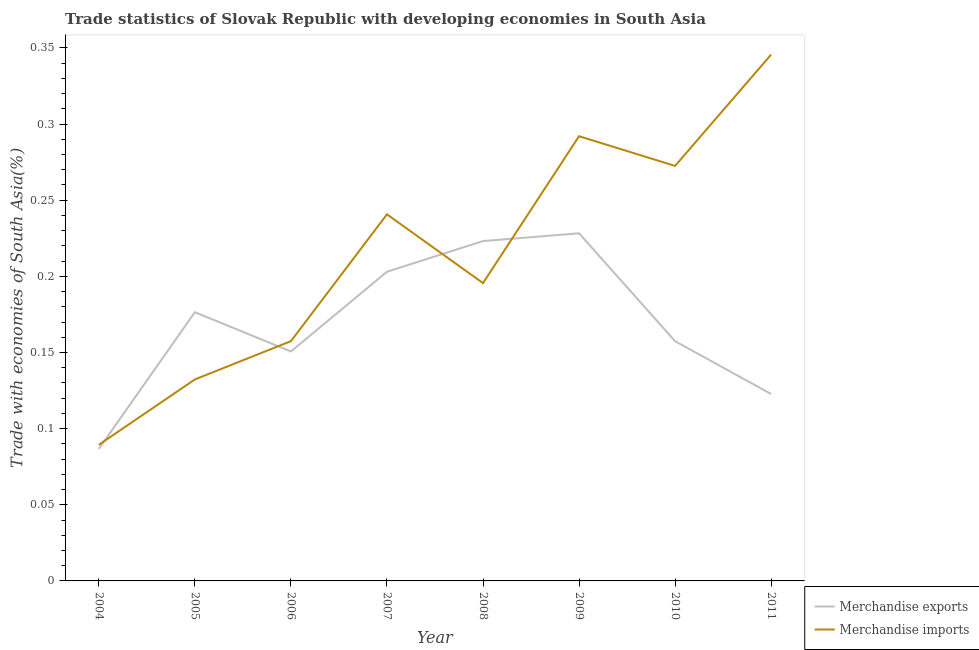Does the line corresponding to merchandise imports intersect with the line corresponding to merchandise exports?
Provide a short and direct response. Yes. Is the number of lines equal to the number of legend labels?
Your answer should be very brief. Yes. What is the merchandise exports in 2004?
Offer a terse response. 0.09. Across all years, what is the maximum merchandise exports?
Ensure brevity in your answer.  0.23. Across all years, what is the minimum merchandise imports?
Keep it short and to the point. 0.09. In which year was the merchandise imports maximum?
Your response must be concise. 2011. In which year was the merchandise imports minimum?
Give a very brief answer. 2004. What is the total merchandise exports in the graph?
Give a very brief answer. 1.35. What is the difference between the merchandise imports in 2006 and that in 2010?
Offer a very short reply. -0.12. What is the difference between the merchandise exports in 2011 and the merchandise imports in 2005?
Offer a very short reply. -0.01. What is the average merchandise exports per year?
Make the answer very short. 0.17. In the year 2004, what is the difference between the merchandise imports and merchandise exports?
Offer a very short reply. 0. In how many years, is the merchandise exports greater than 0.12000000000000001 %?
Keep it short and to the point. 7. What is the ratio of the merchandise imports in 2005 to that in 2006?
Your response must be concise. 0.84. What is the difference between the highest and the second highest merchandise imports?
Make the answer very short. 0.05. What is the difference between the highest and the lowest merchandise imports?
Provide a short and direct response. 0.26. In how many years, is the merchandise exports greater than the average merchandise exports taken over all years?
Your response must be concise. 4. Is the merchandise exports strictly less than the merchandise imports over the years?
Keep it short and to the point. No. How many lines are there?
Your answer should be compact. 2. How many years are there in the graph?
Make the answer very short. 8. What is the difference between two consecutive major ticks on the Y-axis?
Offer a terse response. 0.05. Are the values on the major ticks of Y-axis written in scientific E-notation?
Give a very brief answer. No. What is the title of the graph?
Offer a very short reply. Trade statistics of Slovak Republic with developing economies in South Asia. Does "Non-resident workers" appear as one of the legend labels in the graph?
Your answer should be very brief. No. What is the label or title of the Y-axis?
Your answer should be very brief. Trade with economies of South Asia(%). What is the Trade with economies of South Asia(%) in Merchandise exports in 2004?
Your answer should be compact. 0.09. What is the Trade with economies of South Asia(%) in Merchandise imports in 2004?
Give a very brief answer. 0.09. What is the Trade with economies of South Asia(%) of Merchandise exports in 2005?
Make the answer very short. 0.18. What is the Trade with economies of South Asia(%) of Merchandise imports in 2005?
Offer a very short reply. 0.13. What is the Trade with economies of South Asia(%) in Merchandise exports in 2006?
Ensure brevity in your answer.  0.15. What is the Trade with economies of South Asia(%) of Merchandise imports in 2006?
Your answer should be very brief. 0.16. What is the Trade with economies of South Asia(%) of Merchandise exports in 2007?
Keep it short and to the point. 0.2. What is the Trade with economies of South Asia(%) of Merchandise imports in 2007?
Offer a very short reply. 0.24. What is the Trade with economies of South Asia(%) of Merchandise exports in 2008?
Offer a very short reply. 0.22. What is the Trade with economies of South Asia(%) in Merchandise imports in 2008?
Offer a terse response. 0.2. What is the Trade with economies of South Asia(%) of Merchandise exports in 2009?
Make the answer very short. 0.23. What is the Trade with economies of South Asia(%) of Merchandise imports in 2009?
Your answer should be very brief. 0.29. What is the Trade with economies of South Asia(%) in Merchandise exports in 2010?
Your answer should be compact. 0.16. What is the Trade with economies of South Asia(%) of Merchandise imports in 2010?
Offer a terse response. 0.27. What is the Trade with economies of South Asia(%) of Merchandise exports in 2011?
Your response must be concise. 0.12. What is the Trade with economies of South Asia(%) in Merchandise imports in 2011?
Offer a terse response. 0.35. Across all years, what is the maximum Trade with economies of South Asia(%) in Merchandise exports?
Keep it short and to the point. 0.23. Across all years, what is the maximum Trade with economies of South Asia(%) of Merchandise imports?
Make the answer very short. 0.35. Across all years, what is the minimum Trade with economies of South Asia(%) of Merchandise exports?
Offer a terse response. 0.09. Across all years, what is the minimum Trade with economies of South Asia(%) in Merchandise imports?
Your answer should be compact. 0.09. What is the total Trade with economies of South Asia(%) in Merchandise exports in the graph?
Make the answer very short. 1.35. What is the total Trade with economies of South Asia(%) in Merchandise imports in the graph?
Make the answer very short. 1.73. What is the difference between the Trade with economies of South Asia(%) in Merchandise exports in 2004 and that in 2005?
Offer a very short reply. -0.09. What is the difference between the Trade with economies of South Asia(%) in Merchandise imports in 2004 and that in 2005?
Make the answer very short. -0.04. What is the difference between the Trade with economies of South Asia(%) in Merchandise exports in 2004 and that in 2006?
Offer a very short reply. -0.06. What is the difference between the Trade with economies of South Asia(%) of Merchandise imports in 2004 and that in 2006?
Give a very brief answer. -0.07. What is the difference between the Trade with economies of South Asia(%) of Merchandise exports in 2004 and that in 2007?
Your answer should be compact. -0.12. What is the difference between the Trade with economies of South Asia(%) in Merchandise imports in 2004 and that in 2007?
Make the answer very short. -0.15. What is the difference between the Trade with economies of South Asia(%) of Merchandise exports in 2004 and that in 2008?
Offer a very short reply. -0.14. What is the difference between the Trade with economies of South Asia(%) of Merchandise imports in 2004 and that in 2008?
Give a very brief answer. -0.11. What is the difference between the Trade with economies of South Asia(%) in Merchandise exports in 2004 and that in 2009?
Keep it short and to the point. -0.14. What is the difference between the Trade with economies of South Asia(%) of Merchandise imports in 2004 and that in 2009?
Give a very brief answer. -0.2. What is the difference between the Trade with economies of South Asia(%) of Merchandise exports in 2004 and that in 2010?
Your response must be concise. -0.07. What is the difference between the Trade with economies of South Asia(%) in Merchandise imports in 2004 and that in 2010?
Your response must be concise. -0.18. What is the difference between the Trade with economies of South Asia(%) in Merchandise exports in 2004 and that in 2011?
Your answer should be compact. -0.04. What is the difference between the Trade with economies of South Asia(%) in Merchandise imports in 2004 and that in 2011?
Offer a terse response. -0.26. What is the difference between the Trade with economies of South Asia(%) of Merchandise exports in 2005 and that in 2006?
Provide a succinct answer. 0.03. What is the difference between the Trade with economies of South Asia(%) of Merchandise imports in 2005 and that in 2006?
Your answer should be compact. -0.03. What is the difference between the Trade with economies of South Asia(%) of Merchandise exports in 2005 and that in 2007?
Provide a short and direct response. -0.03. What is the difference between the Trade with economies of South Asia(%) in Merchandise imports in 2005 and that in 2007?
Provide a succinct answer. -0.11. What is the difference between the Trade with economies of South Asia(%) in Merchandise exports in 2005 and that in 2008?
Offer a terse response. -0.05. What is the difference between the Trade with economies of South Asia(%) in Merchandise imports in 2005 and that in 2008?
Give a very brief answer. -0.06. What is the difference between the Trade with economies of South Asia(%) of Merchandise exports in 2005 and that in 2009?
Provide a short and direct response. -0.05. What is the difference between the Trade with economies of South Asia(%) of Merchandise imports in 2005 and that in 2009?
Offer a very short reply. -0.16. What is the difference between the Trade with economies of South Asia(%) of Merchandise exports in 2005 and that in 2010?
Your answer should be compact. 0.02. What is the difference between the Trade with economies of South Asia(%) of Merchandise imports in 2005 and that in 2010?
Ensure brevity in your answer.  -0.14. What is the difference between the Trade with economies of South Asia(%) of Merchandise exports in 2005 and that in 2011?
Your answer should be compact. 0.05. What is the difference between the Trade with economies of South Asia(%) in Merchandise imports in 2005 and that in 2011?
Keep it short and to the point. -0.21. What is the difference between the Trade with economies of South Asia(%) in Merchandise exports in 2006 and that in 2007?
Ensure brevity in your answer.  -0.05. What is the difference between the Trade with economies of South Asia(%) of Merchandise imports in 2006 and that in 2007?
Provide a short and direct response. -0.08. What is the difference between the Trade with economies of South Asia(%) in Merchandise exports in 2006 and that in 2008?
Your answer should be compact. -0.07. What is the difference between the Trade with economies of South Asia(%) of Merchandise imports in 2006 and that in 2008?
Ensure brevity in your answer.  -0.04. What is the difference between the Trade with economies of South Asia(%) of Merchandise exports in 2006 and that in 2009?
Provide a succinct answer. -0.08. What is the difference between the Trade with economies of South Asia(%) in Merchandise imports in 2006 and that in 2009?
Provide a succinct answer. -0.13. What is the difference between the Trade with economies of South Asia(%) in Merchandise exports in 2006 and that in 2010?
Make the answer very short. -0.01. What is the difference between the Trade with economies of South Asia(%) in Merchandise imports in 2006 and that in 2010?
Your answer should be very brief. -0.12. What is the difference between the Trade with economies of South Asia(%) in Merchandise exports in 2006 and that in 2011?
Offer a terse response. 0.03. What is the difference between the Trade with economies of South Asia(%) in Merchandise imports in 2006 and that in 2011?
Ensure brevity in your answer.  -0.19. What is the difference between the Trade with economies of South Asia(%) in Merchandise exports in 2007 and that in 2008?
Provide a short and direct response. -0.02. What is the difference between the Trade with economies of South Asia(%) of Merchandise imports in 2007 and that in 2008?
Provide a short and direct response. 0.05. What is the difference between the Trade with economies of South Asia(%) of Merchandise exports in 2007 and that in 2009?
Your answer should be compact. -0.03. What is the difference between the Trade with economies of South Asia(%) in Merchandise imports in 2007 and that in 2009?
Your answer should be very brief. -0.05. What is the difference between the Trade with economies of South Asia(%) of Merchandise exports in 2007 and that in 2010?
Offer a very short reply. 0.05. What is the difference between the Trade with economies of South Asia(%) of Merchandise imports in 2007 and that in 2010?
Offer a very short reply. -0.03. What is the difference between the Trade with economies of South Asia(%) of Merchandise exports in 2007 and that in 2011?
Ensure brevity in your answer.  0.08. What is the difference between the Trade with economies of South Asia(%) in Merchandise imports in 2007 and that in 2011?
Provide a succinct answer. -0.1. What is the difference between the Trade with economies of South Asia(%) of Merchandise exports in 2008 and that in 2009?
Your answer should be compact. -0.01. What is the difference between the Trade with economies of South Asia(%) in Merchandise imports in 2008 and that in 2009?
Provide a short and direct response. -0.1. What is the difference between the Trade with economies of South Asia(%) of Merchandise exports in 2008 and that in 2010?
Offer a terse response. 0.07. What is the difference between the Trade with economies of South Asia(%) of Merchandise imports in 2008 and that in 2010?
Offer a terse response. -0.08. What is the difference between the Trade with economies of South Asia(%) of Merchandise exports in 2008 and that in 2011?
Offer a very short reply. 0.1. What is the difference between the Trade with economies of South Asia(%) of Merchandise exports in 2009 and that in 2010?
Offer a terse response. 0.07. What is the difference between the Trade with economies of South Asia(%) of Merchandise imports in 2009 and that in 2010?
Offer a very short reply. 0.02. What is the difference between the Trade with economies of South Asia(%) in Merchandise exports in 2009 and that in 2011?
Offer a terse response. 0.11. What is the difference between the Trade with economies of South Asia(%) of Merchandise imports in 2009 and that in 2011?
Keep it short and to the point. -0.05. What is the difference between the Trade with economies of South Asia(%) of Merchandise exports in 2010 and that in 2011?
Your answer should be very brief. 0.03. What is the difference between the Trade with economies of South Asia(%) in Merchandise imports in 2010 and that in 2011?
Ensure brevity in your answer.  -0.07. What is the difference between the Trade with economies of South Asia(%) of Merchandise exports in 2004 and the Trade with economies of South Asia(%) of Merchandise imports in 2005?
Make the answer very short. -0.05. What is the difference between the Trade with economies of South Asia(%) in Merchandise exports in 2004 and the Trade with economies of South Asia(%) in Merchandise imports in 2006?
Provide a short and direct response. -0.07. What is the difference between the Trade with economies of South Asia(%) of Merchandise exports in 2004 and the Trade with economies of South Asia(%) of Merchandise imports in 2007?
Provide a succinct answer. -0.15. What is the difference between the Trade with economies of South Asia(%) of Merchandise exports in 2004 and the Trade with economies of South Asia(%) of Merchandise imports in 2008?
Provide a short and direct response. -0.11. What is the difference between the Trade with economies of South Asia(%) in Merchandise exports in 2004 and the Trade with economies of South Asia(%) in Merchandise imports in 2009?
Ensure brevity in your answer.  -0.21. What is the difference between the Trade with economies of South Asia(%) in Merchandise exports in 2004 and the Trade with economies of South Asia(%) in Merchandise imports in 2010?
Keep it short and to the point. -0.19. What is the difference between the Trade with economies of South Asia(%) in Merchandise exports in 2004 and the Trade with economies of South Asia(%) in Merchandise imports in 2011?
Keep it short and to the point. -0.26. What is the difference between the Trade with economies of South Asia(%) in Merchandise exports in 2005 and the Trade with economies of South Asia(%) in Merchandise imports in 2006?
Provide a succinct answer. 0.02. What is the difference between the Trade with economies of South Asia(%) in Merchandise exports in 2005 and the Trade with economies of South Asia(%) in Merchandise imports in 2007?
Make the answer very short. -0.06. What is the difference between the Trade with economies of South Asia(%) in Merchandise exports in 2005 and the Trade with economies of South Asia(%) in Merchandise imports in 2008?
Offer a very short reply. -0.02. What is the difference between the Trade with economies of South Asia(%) of Merchandise exports in 2005 and the Trade with economies of South Asia(%) of Merchandise imports in 2009?
Provide a succinct answer. -0.12. What is the difference between the Trade with economies of South Asia(%) of Merchandise exports in 2005 and the Trade with economies of South Asia(%) of Merchandise imports in 2010?
Provide a succinct answer. -0.1. What is the difference between the Trade with economies of South Asia(%) in Merchandise exports in 2005 and the Trade with economies of South Asia(%) in Merchandise imports in 2011?
Offer a terse response. -0.17. What is the difference between the Trade with economies of South Asia(%) in Merchandise exports in 2006 and the Trade with economies of South Asia(%) in Merchandise imports in 2007?
Make the answer very short. -0.09. What is the difference between the Trade with economies of South Asia(%) of Merchandise exports in 2006 and the Trade with economies of South Asia(%) of Merchandise imports in 2008?
Your response must be concise. -0.04. What is the difference between the Trade with economies of South Asia(%) of Merchandise exports in 2006 and the Trade with economies of South Asia(%) of Merchandise imports in 2009?
Provide a succinct answer. -0.14. What is the difference between the Trade with economies of South Asia(%) of Merchandise exports in 2006 and the Trade with economies of South Asia(%) of Merchandise imports in 2010?
Your answer should be compact. -0.12. What is the difference between the Trade with economies of South Asia(%) in Merchandise exports in 2006 and the Trade with economies of South Asia(%) in Merchandise imports in 2011?
Provide a short and direct response. -0.19. What is the difference between the Trade with economies of South Asia(%) in Merchandise exports in 2007 and the Trade with economies of South Asia(%) in Merchandise imports in 2008?
Offer a very short reply. 0.01. What is the difference between the Trade with economies of South Asia(%) of Merchandise exports in 2007 and the Trade with economies of South Asia(%) of Merchandise imports in 2009?
Your response must be concise. -0.09. What is the difference between the Trade with economies of South Asia(%) in Merchandise exports in 2007 and the Trade with economies of South Asia(%) in Merchandise imports in 2010?
Provide a succinct answer. -0.07. What is the difference between the Trade with economies of South Asia(%) in Merchandise exports in 2007 and the Trade with economies of South Asia(%) in Merchandise imports in 2011?
Keep it short and to the point. -0.14. What is the difference between the Trade with economies of South Asia(%) in Merchandise exports in 2008 and the Trade with economies of South Asia(%) in Merchandise imports in 2009?
Make the answer very short. -0.07. What is the difference between the Trade with economies of South Asia(%) in Merchandise exports in 2008 and the Trade with economies of South Asia(%) in Merchandise imports in 2010?
Give a very brief answer. -0.05. What is the difference between the Trade with economies of South Asia(%) in Merchandise exports in 2008 and the Trade with economies of South Asia(%) in Merchandise imports in 2011?
Make the answer very short. -0.12. What is the difference between the Trade with economies of South Asia(%) of Merchandise exports in 2009 and the Trade with economies of South Asia(%) of Merchandise imports in 2010?
Give a very brief answer. -0.04. What is the difference between the Trade with economies of South Asia(%) in Merchandise exports in 2009 and the Trade with economies of South Asia(%) in Merchandise imports in 2011?
Your answer should be compact. -0.12. What is the difference between the Trade with economies of South Asia(%) in Merchandise exports in 2010 and the Trade with economies of South Asia(%) in Merchandise imports in 2011?
Your answer should be very brief. -0.19. What is the average Trade with economies of South Asia(%) of Merchandise exports per year?
Provide a succinct answer. 0.17. What is the average Trade with economies of South Asia(%) in Merchandise imports per year?
Your answer should be very brief. 0.22. In the year 2004, what is the difference between the Trade with economies of South Asia(%) in Merchandise exports and Trade with economies of South Asia(%) in Merchandise imports?
Keep it short and to the point. -0. In the year 2005, what is the difference between the Trade with economies of South Asia(%) of Merchandise exports and Trade with economies of South Asia(%) of Merchandise imports?
Give a very brief answer. 0.04. In the year 2006, what is the difference between the Trade with economies of South Asia(%) in Merchandise exports and Trade with economies of South Asia(%) in Merchandise imports?
Offer a very short reply. -0.01. In the year 2007, what is the difference between the Trade with economies of South Asia(%) of Merchandise exports and Trade with economies of South Asia(%) of Merchandise imports?
Your response must be concise. -0.04. In the year 2008, what is the difference between the Trade with economies of South Asia(%) of Merchandise exports and Trade with economies of South Asia(%) of Merchandise imports?
Provide a succinct answer. 0.03. In the year 2009, what is the difference between the Trade with economies of South Asia(%) in Merchandise exports and Trade with economies of South Asia(%) in Merchandise imports?
Provide a short and direct response. -0.06. In the year 2010, what is the difference between the Trade with economies of South Asia(%) in Merchandise exports and Trade with economies of South Asia(%) in Merchandise imports?
Make the answer very short. -0.12. In the year 2011, what is the difference between the Trade with economies of South Asia(%) in Merchandise exports and Trade with economies of South Asia(%) in Merchandise imports?
Offer a terse response. -0.22. What is the ratio of the Trade with economies of South Asia(%) of Merchandise exports in 2004 to that in 2005?
Keep it short and to the point. 0.49. What is the ratio of the Trade with economies of South Asia(%) in Merchandise imports in 2004 to that in 2005?
Give a very brief answer. 0.68. What is the ratio of the Trade with economies of South Asia(%) of Merchandise exports in 2004 to that in 2006?
Give a very brief answer. 0.58. What is the ratio of the Trade with economies of South Asia(%) in Merchandise imports in 2004 to that in 2006?
Your answer should be compact. 0.57. What is the ratio of the Trade with economies of South Asia(%) of Merchandise exports in 2004 to that in 2007?
Your answer should be very brief. 0.43. What is the ratio of the Trade with economies of South Asia(%) of Merchandise imports in 2004 to that in 2007?
Provide a succinct answer. 0.37. What is the ratio of the Trade with economies of South Asia(%) of Merchandise exports in 2004 to that in 2008?
Offer a very short reply. 0.39. What is the ratio of the Trade with economies of South Asia(%) in Merchandise imports in 2004 to that in 2008?
Provide a short and direct response. 0.46. What is the ratio of the Trade with economies of South Asia(%) of Merchandise exports in 2004 to that in 2009?
Make the answer very short. 0.38. What is the ratio of the Trade with economies of South Asia(%) of Merchandise imports in 2004 to that in 2009?
Your answer should be compact. 0.31. What is the ratio of the Trade with economies of South Asia(%) in Merchandise exports in 2004 to that in 2010?
Ensure brevity in your answer.  0.55. What is the ratio of the Trade with economies of South Asia(%) in Merchandise imports in 2004 to that in 2010?
Offer a terse response. 0.33. What is the ratio of the Trade with economies of South Asia(%) of Merchandise exports in 2004 to that in 2011?
Your answer should be compact. 0.71. What is the ratio of the Trade with economies of South Asia(%) in Merchandise imports in 2004 to that in 2011?
Ensure brevity in your answer.  0.26. What is the ratio of the Trade with economies of South Asia(%) of Merchandise exports in 2005 to that in 2006?
Provide a short and direct response. 1.17. What is the ratio of the Trade with economies of South Asia(%) in Merchandise imports in 2005 to that in 2006?
Your answer should be compact. 0.84. What is the ratio of the Trade with economies of South Asia(%) in Merchandise exports in 2005 to that in 2007?
Offer a very short reply. 0.87. What is the ratio of the Trade with economies of South Asia(%) of Merchandise imports in 2005 to that in 2007?
Offer a very short reply. 0.55. What is the ratio of the Trade with economies of South Asia(%) of Merchandise exports in 2005 to that in 2008?
Make the answer very short. 0.79. What is the ratio of the Trade with economies of South Asia(%) in Merchandise imports in 2005 to that in 2008?
Your response must be concise. 0.68. What is the ratio of the Trade with economies of South Asia(%) in Merchandise exports in 2005 to that in 2009?
Keep it short and to the point. 0.77. What is the ratio of the Trade with economies of South Asia(%) in Merchandise imports in 2005 to that in 2009?
Ensure brevity in your answer.  0.45. What is the ratio of the Trade with economies of South Asia(%) of Merchandise exports in 2005 to that in 2010?
Your answer should be very brief. 1.12. What is the ratio of the Trade with economies of South Asia(%) in Merchandise imports in 2005 to that in 2010?
Make the answer very short. 0.49. What is the ratio of the Trade with economies of South Asia(%) of Merchandise exports in 2005 to that in 2011?
Keep it short and to the point. 1.44. What is the ratio of the Trade with economies of South Asia(%) of Merchandise imports in 2005 to that in 2011?
Your response must be concise. 0.38. What is the ratio of the Trade with economies of South Asia(%) of Merchandise exports in 2006 to that in 2007?
Ensure brevity in your answer.  0.74. What is the ratio of the Trade with economies of South Asia(%) of Merchandise imports in 2006 to that in 2007?
Ensure brevity in your answer.  0.65. What is the ratio of the Trade with economies of South Asia(%) of Merchandise exports in 2006 to that in 2008?
Ensure brevity in your answer.  0.68. What is the ratio of the Trade with economies of South Asia(%) in Merchandise imports in 2006 to that in 2008?
Offer a very short reply. 0.81. What is the ratio of the Trade with economies of South Asia(%) in Merchandise exports in 2006 to that in 2009?
Offer a terse response. 0.66. What is the ratio of the Trade with economies of South Asia(%) in Merchandise imports in 2006 to that in 2009?
Ensure brevity in your answer.  0.54. What is the ratio of the Trade with economies of South Asia(%) in Merchandise exports in 2006 to that in 2010?
Offer a terse response. 0.96. What is the ratio of the Trade with economies of South Asia(%) of Merchandise imports in 2006 to that in 2010?
Make the answer very short. 0.58. What is the ratio of the Trade with economies of South Asia(%) in Merchandise exports in 2006 to that in 2011?
Make the answer very short. 1.23. What is the ratio of the Trade with economies of South Asia(%) of Merchandise imports in 2006 to that in 2011?
Keep it short and to the point. 0.46. What is the ratio of the Trade with economies of South Asia(%) in Merchandise exports in 2007 to that in 2008?
Offer a terse response. 0.91. What is the ratio of the Trade with economies of South Asia(%) in Merchandise imports in 2007 to that in 2008?
Offer a terse response. 1.23. What is the ratio of the Trade with economies of South Asia(%) of Merchandise exports in 2007 to that in 2009?
Offer a terse response. 0.89. What is the ratio of the Trade with economies of South Asia(%) of Merchandise imports in 2007 to that in 2009?
Offer a very short reply. 0.82. What is the ratio of the Trade with economies of South Asia(%) of Merchandise exports in 2007 to that in 2010?
Provide a short and direct response. 1.29. What is the ratio of the Trade with economies of South Asia(%) in Merchandise imports in 2007 to that in 2010?
Keep it short and to the point. 0.88. What is the ratio of the Trade with economies of South Asia(%) of Merchandise exports in 2007 to that in 2011?
Ensure brevity in your answer.  1.65. What is the ratio of the Trade with economies of South Asia(%) in Merchandise imports in 2007 to that in 2011?
Give a very brief answer. 0.7. What is the ratio of the Trade with economies of South Asia(%) of Merchandise exports in 2008 to that in 2009?
Ensure brevity in your answer.  0.98. What is the ratio of the Trade with economies of South Asia(%) in Merchandise imports in 2008 to that in 2009?
Your answer should be very brief. 0.67. What is the ratio of the Trade with economies of South Asia(%) of Merchandise exports in 2008 to that in 2010?
Make the answer very short. 1.42. What is the ratio of the Trade with economies of South Asia(%) of Merchandise imports in 2008 to that in 2010?
Your response must be concise. 0.72. What is the ratio of the Trade with economies of South Asia(%) of Merchandise exports in 2008 to that in 2011?
Provide a short and direct response. 1.82. What is the ratio of the Trade with economies of South Asia(%) of Merchandise imports in 2008 to that in 2011?
Ensure brevity in your answer.  0.57. What is the ratio of the Trade with economies of South Asia(%) of Merchandise exports in 2009 to that in 2010?
Give a very brief answer. 1.45. What is the ratio of the Trade with economies of South Asia(%) in Merchandise imports in 2009 to that in 2010?
Ensure brevity in your answer.  1.07. What is the ratio of the Trade with economies of South Asia(%) of Merchandise exports in 2009 to that in 2011?
Your answer should be compact. 1.86. What is the ratio of the Trade with economies of South Asia(%) in Merchandise imports in 2009 to that in 2011?
Your answer should be compact. 0.84. What is the ratio of the Trade with economies of South Asia(%) of Merchandise exports in 2010 to that in 2011?
Your answer should be compact. 1.28. What is the ratio of the Trade with economies of South Asia(%) of Merchandise imports in 2010 to that in 2011?
Provide a short and direct response. 0.79. What is the difference between the highest and the second highest Trade with economies of South Asia(%) of Merchandise exports?
Ensure brevity in your answer.  0.01. What is the difference between the highest and the second highest Trade with economies of South Asia(%) in Merchandise imports?
Make the answer very short. 0.05. What is the difference between the highest and the lowest Trade with economies of South Asia(%) of Merchandise exports?
Give a very brief answer. 0.14. What is the difference between the highest and the lowest Trade with economies of South Asia(%) of Merchandise imports?
Keep it short and to the point. 0.26. 